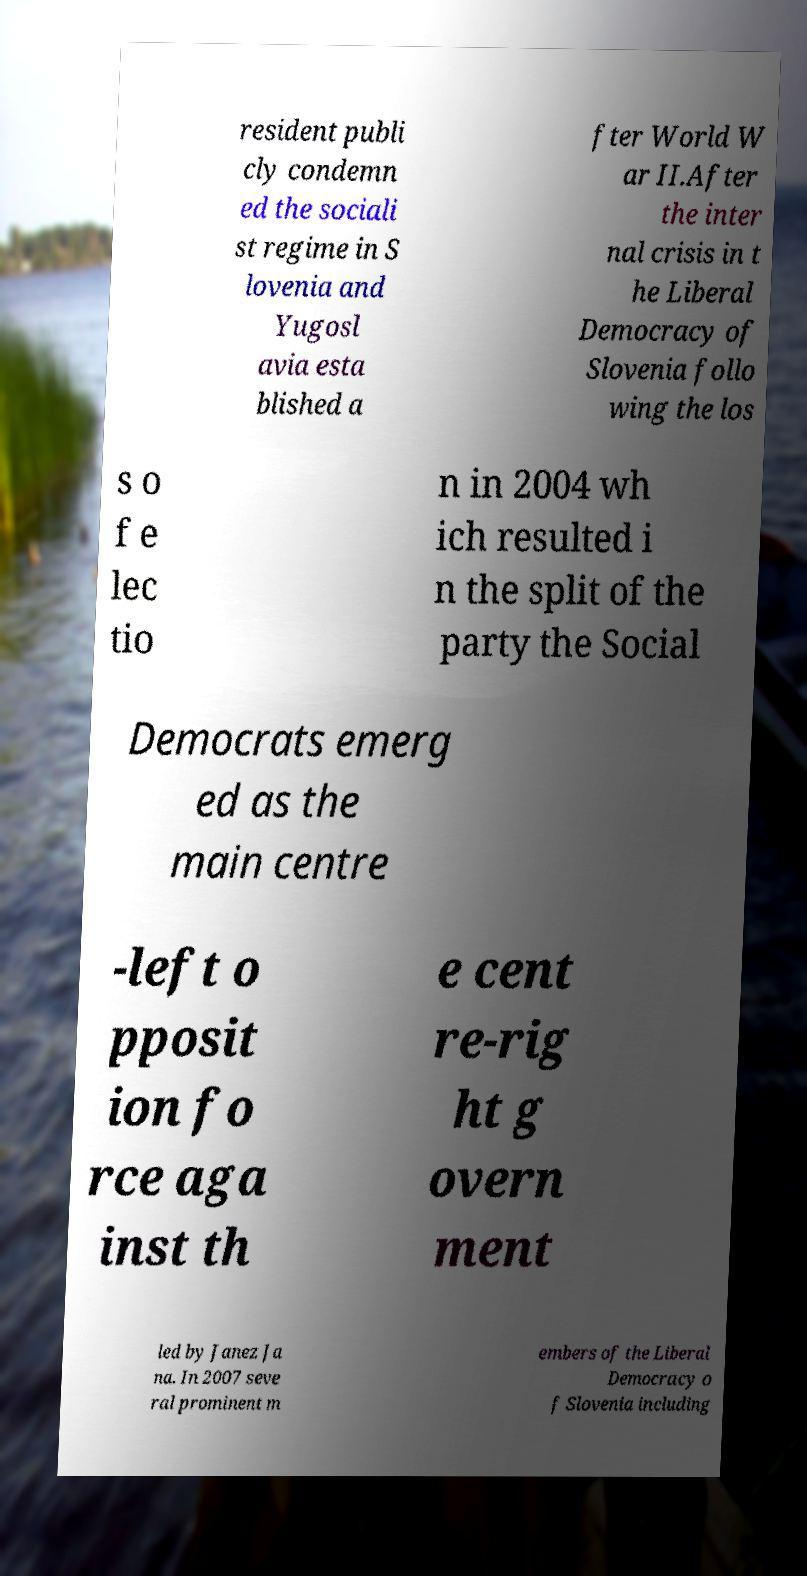Please read and relay the text visible in this image. What does it say? resident publi cly condemn ed the sociali st regime in S lovenia and Yugosl avia esta blished a fter World W ar II.After the inter nal crisis in t he Liberal Democracy of Slovenia follo wing the los s o f e lec tio n in 2004 wh ich resulted i n the split of the party the Social Democrats emerg ed as the main centre -left o pposit ion fo rce aga inst th e cent re-rig ht g overn ment led by Janez Ja na. In 2007 seve ral prominent m embers of the Liberal Democracy o f Slovenia including 